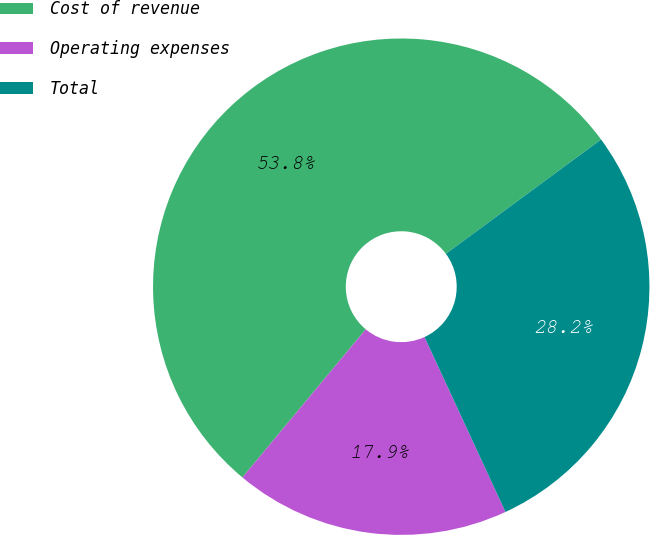Convert chart to OTSL. <chart><loc_0><loc_0><loc_500><loc_500><pie_chart><fcel>Cost of revenue<fcel>Operating expenses<fcel>Total<nl><fcel>53.85%<fcel>17.95%<fcel>28.21%<nl></chart> 